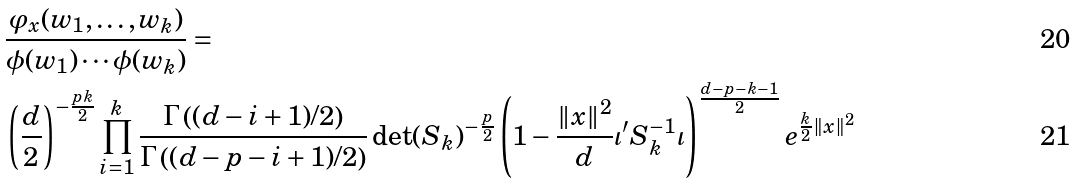Convert formula to latex. <formula><loc_0><loc_0><loc_500><loc_500>& \frac { \varphi _ { x } ( w _ { 1 } , \dots , w _ { k } ) } { \phi ( w _ { 1 } ) \cdots \phi ( w _ { k } ) } = \\ & \left ( \frac { d } { 2 } \right ) ^ { - \frac { p k } { 2 } } \prod _ { i = 1 } ^ { k } \frac { \Gamma \left ( ( d - i + 1 ) / 2 \right ) } { \Gamma \left ( ( d - p - i + 1 ) / 2 \right ) } \det ( S _ { k } ) ^ { - \frac { p } { 2 } } \left ( 1 - \frac { \| x \| ^ { 2 } } { d } \iota ^ { \prime } S _ { k } ^ { - 1 } \iota \right ) ^ { \frac { d - p - k - 1 } { 2 } } e ^ { \frac { k } 2 \| x \| ^ { 2 } }</formula> 